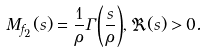<formula> <loc_0><loc_0><loc_500><loc_500>M _ { f _ { 2 } } ( s ) = \frac { 1 } { \rho } \Gamma { \left ( \frac { s } { \rho } \right ) } , \Re ( s ) > 0 .</formula> 